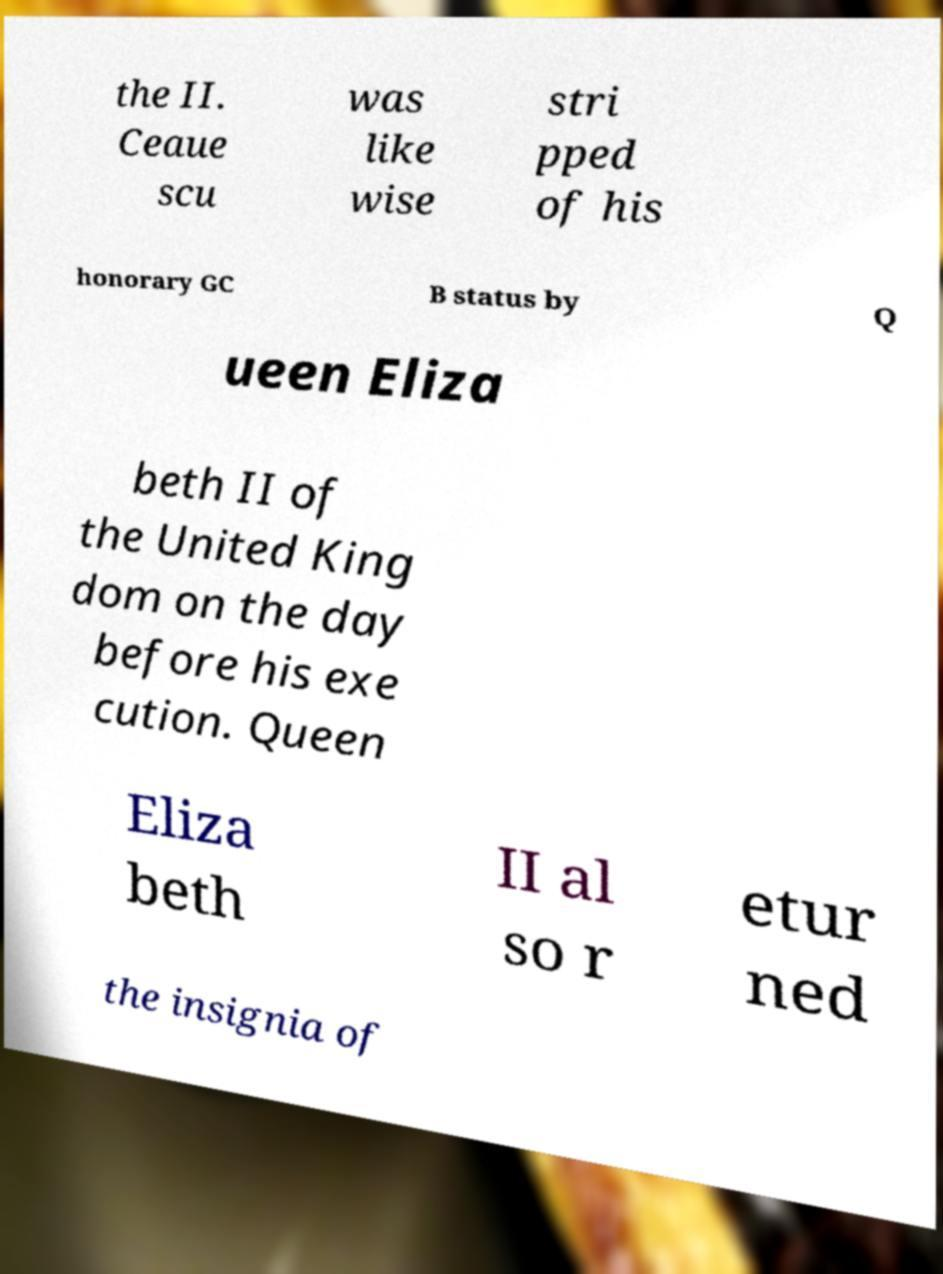For documentation purposes, I need the text within this image transcribed. Could you provide that? the II. Ceaue scu was like wise stri pped of his honorary GC B status by Q ueen Eliza beth II of the United King dom on the day before his exe cution. Queen Eliza beth II al so r etur ned the insignia of 